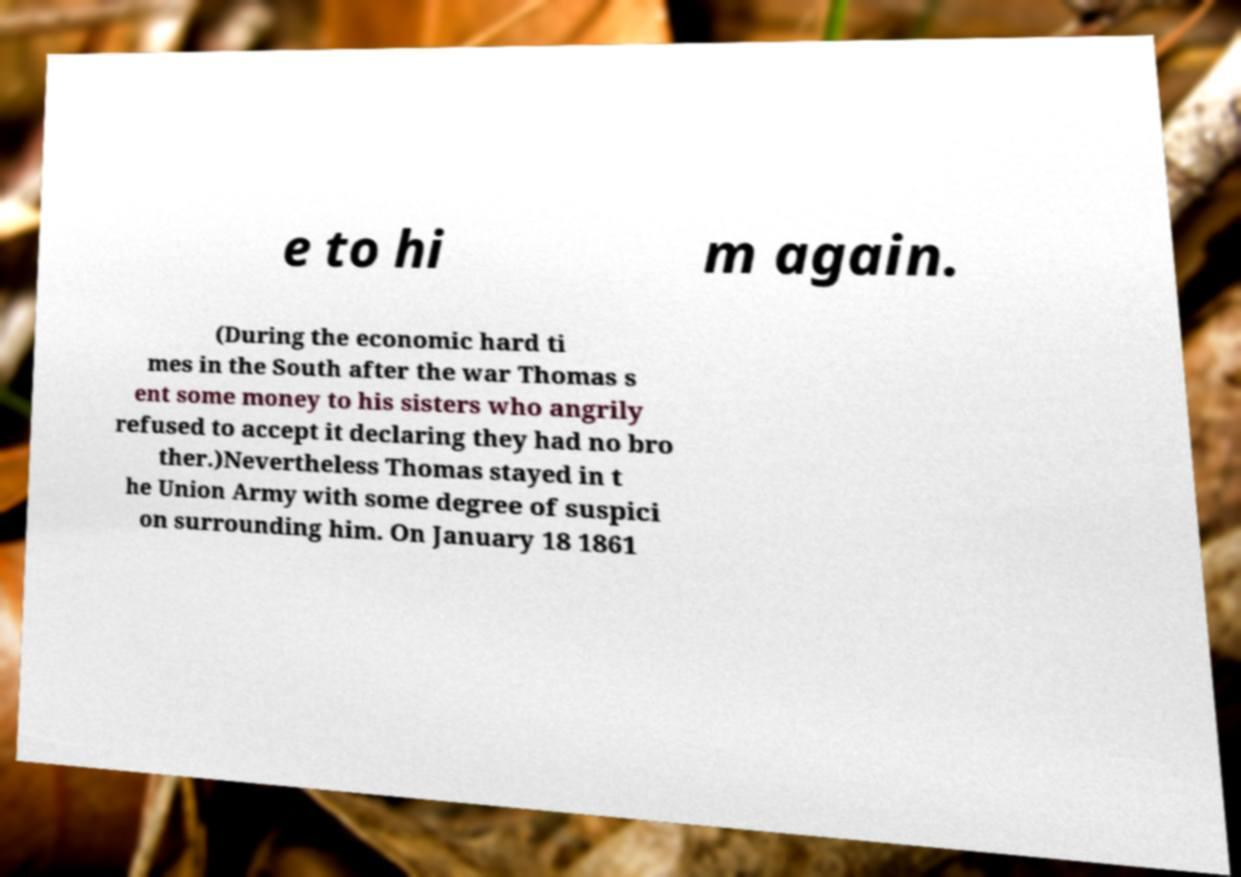Can you accurately transcribe the text from the provided image for me? e to hi m again. (During the economic hard ti mes in the South after the war Thomas s ent some money to his sisters who angrily refused to accept it declaring they had no bro ther.)Nevertheless Thomas stayed in t he Union Army with some degree of suspici on surrounding him. On January 18 1861 